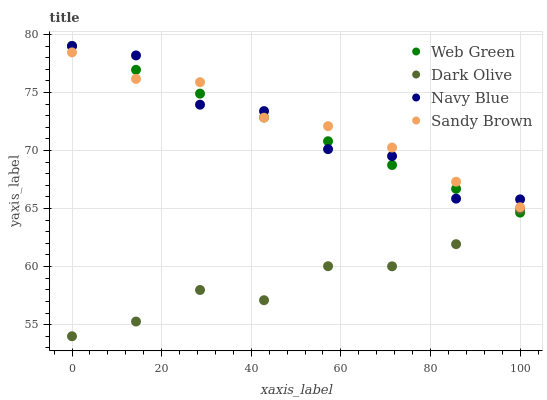Does Dark Olive have the minimum area under the curve?
Answer yes or no. Yes. Does Sandy Brown have the maximum area under the curve?
Answer yes or no. Yes. Does Sandy Brown have the minimum area under the curve?
Answer yes or no. No. Does Dark Olive have the maximum area under the curve?
Answer yes or no. No. Is Web Green the smoothest?
Answer yes or no. Yes. Is Navy Blue the roughest?
Answer yes or no. Yes. Is Dark Olive the smoothest?
Answer yes or no. No. Is Dark Olive the roughest?
Answer yes or no. No. Does Dark Olive have the lowest value?
Answer yes or no. Yes. Does Sandy Brown have the lowest value?
Answer yes or no. No. Does Web Green have the highest value?
Answer yes or no. Yes. Does Sandy Brown have the highest value?
Answer yes or no. No. Is Dark Olive less than Sandy Brown?
Answer yes or no. Yes. Is Sandy Brown greater than Dark Olive?
Answer yes or no. Yes. Does Navy Blue intersect Web Green?
Answer yes or no. Yes. Is Navy Blue less than Web Green?
Answer yes or no. No. Is Navy Blue greater than Web Green?
Answer yes or no. No. Does Dark Olive intersect Sandy Brown?
Answer yes or no. No. 